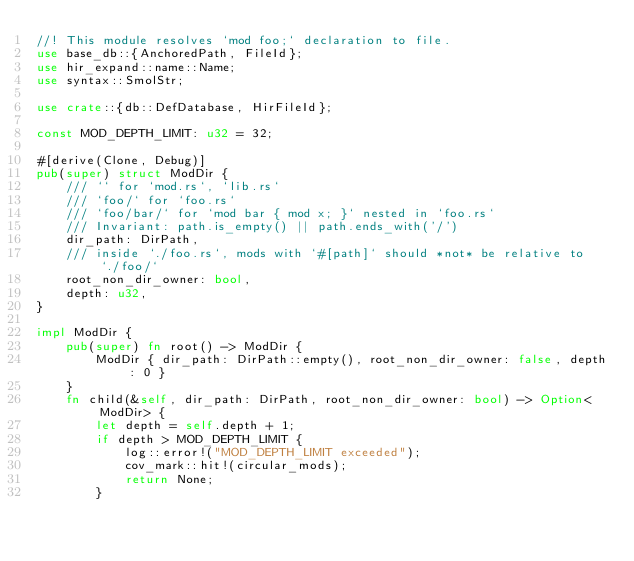<code> <loc_0><loc_0><loc_500><loc_500><_Rust_>//! This module resolves `mod foo;` declaration to file.
use base_db::{AnchoredPath, FileId};
use hir_expand::name::Name;
use syntax::SmolStr;

use crate::{db::DefDatabase, HirFileId};

const MOD_DEPTH_LIMIT: u32 = 32;

#[derive(Clone, Debug)]
pub(super) struct ModDir {
    /// `` for `mod.rs`, `lib.rs`
    /// `foo/` for `foo.rs`
    /// `foo/bar/` for `mod bar { mod x; }` nested in `foo.rs`
    /// Invariant: path.is_empty() || path.ends_with('/')
    dir_path: DirPath,
    /// inside `./foo.rs`, mods with `#[path]` should *not* be relative to `./foo/`
    root_non_dir_owner: bool,
    depth: u32,
}

impl ModDir {
    pub(super) fn root() -> ModDir {
        ModDir { dir_path: DirPath::empty(), root_non_dir_owner: false, depth: 0 }
    }
    fn child(&self, dir_path: DirPath, root_non_dir_owner: bool) -> Option<ModDir> {
        let depth = self.depth + 1;
        if depth > MOD_DEPTH_LIMIT {
            log::error!("MOD_DEPTH_LIMIT exceeded");
            cov_mark::hit!(circular_mods);
            return None;
        }</code> 